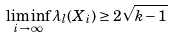Convert formula to latex. <formula><loc_0><loc_0><loc_500><loc_500>\liminf _ { i \rightarrow \infty } \lambda _ { l } ( X _ { i } ) \geq 2 \sqrt { k - 1 }</formula> 